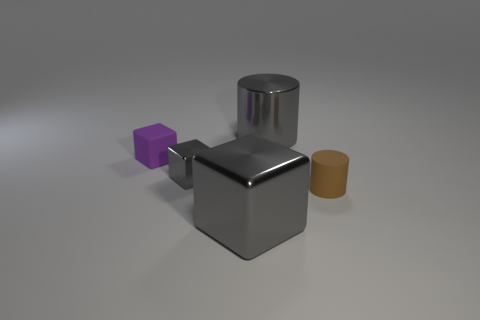Subtract all gray cylinders. How many gray blocks are left? 2 Subtract all gray cubes. How many cubes are left? 1 Add 2 purple matte cubes. How many objects exist? 7 Subtract 1 cubes. How many cubes are left? 2 Subtract all purple cubes. How many cubes are left? 2 Subtract all blocks. How many objects are left? 2 Subtract all yellow blocks. Subtract all gray cylinders. How many blocks are left? 3 Subtract all brown shiny things. Subtract all purple objects. How many objects are left? 4 Add 5 big gray blocks. How many big gray blocks are left? 6 Add 2 tiny gray shiny objects. How many tiny gray shiny objects exist? 3 